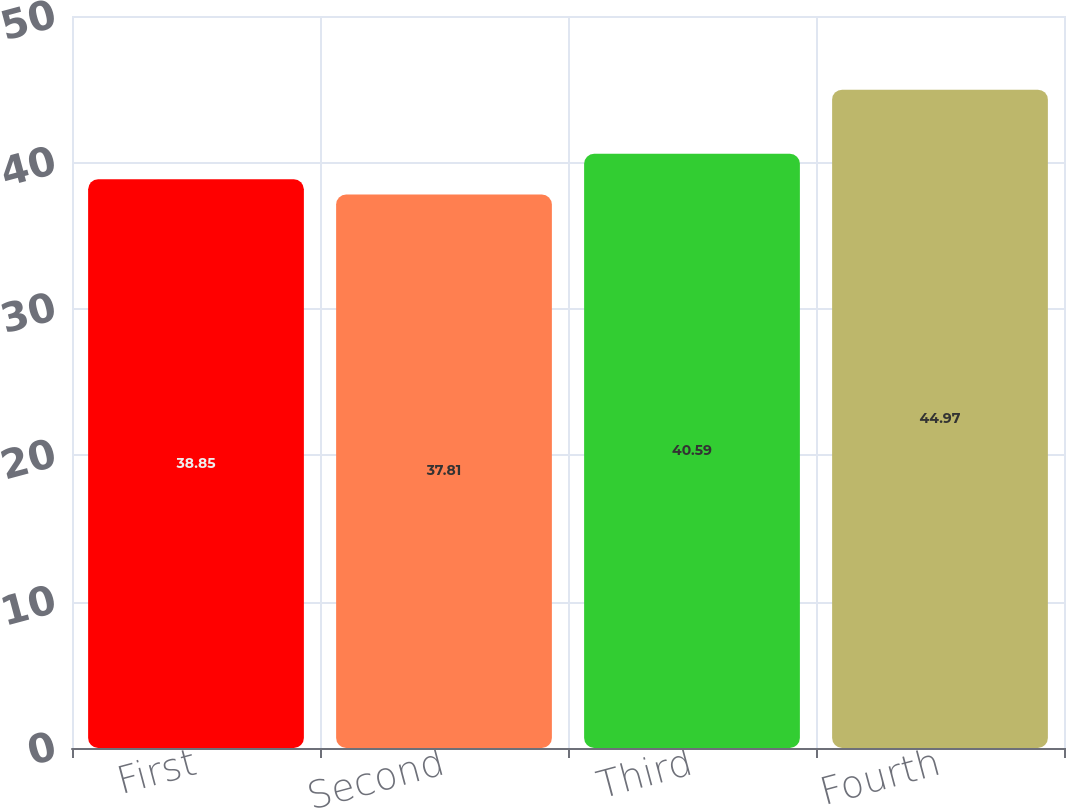<chart> <loc_0><loc_0><loc_500><loc_500><bar_chart><fcel>First<fcel>Second<fcel>Third<fcel>Fourth<nl><fcel>38.85<fcel>37.81<fcel>40.59<fcel>44.97<nl></chart> 